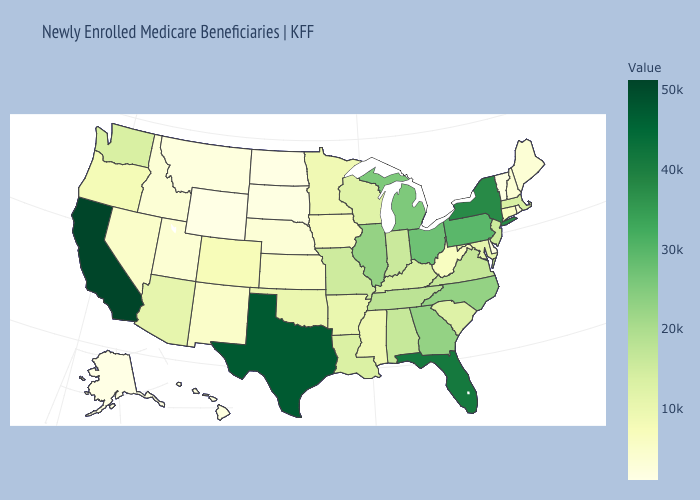Among the states that border New Hampshire , does Massachusetts have the highest value?
Be succinct. Yes. Does Wyoming have the highest value in the West?
Write a very short answer. No. Among the states that border New Jersey , which have the highest value?
Quick response, please. New York. Does Tennessee have the lowest value in the USA?
Answer briefly. No. 